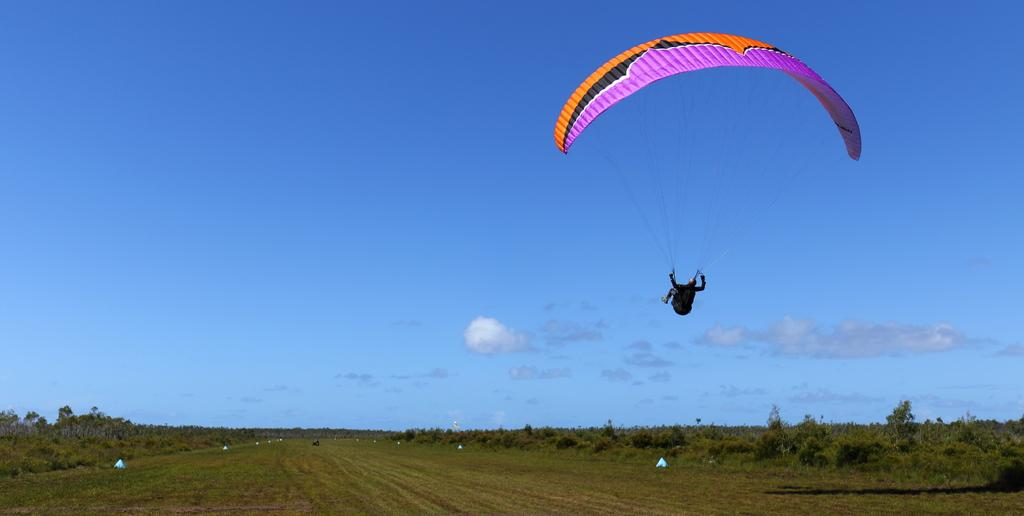What is the person in the image doing? The person in the image is flying with a parachute. What type of terrain is visible in the image? There is grass visible in the image, and there are also trees present. What else can be seen in the image besides the person and the terrain? There are some objects in the image. What is visible in the background of the image? The sky is visible in the background of the image. How much fuel is required for the person to fly with the parachute in the image? There is no mention of fuel in the image, as the person is flying with a parachute, which does not require fuel. 